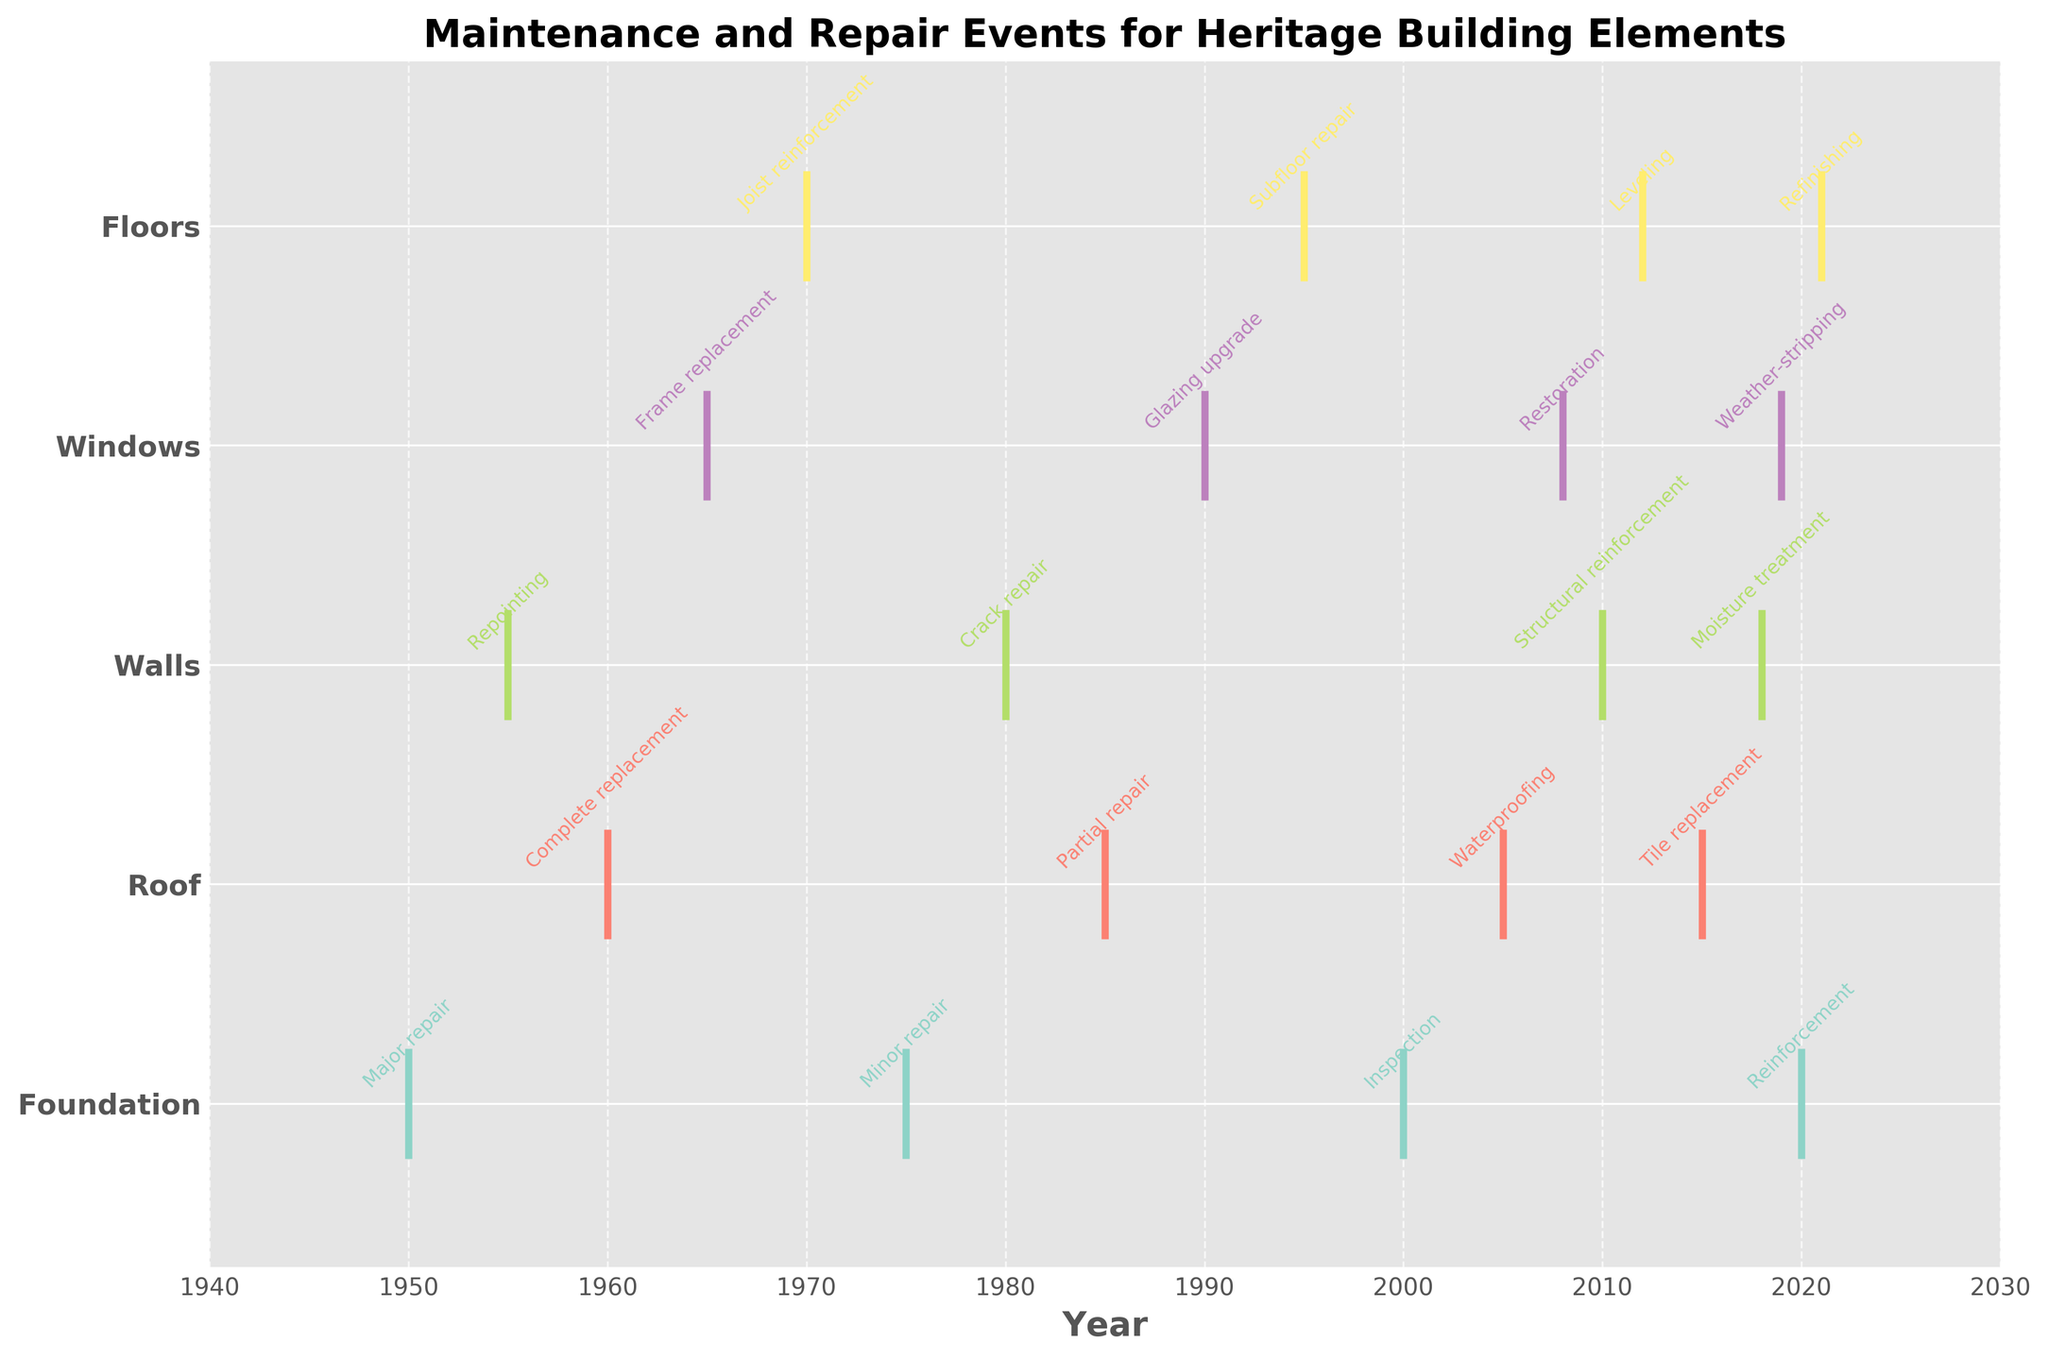What is the title of the plot? The title is usually found at the top center of the plot, and it is used to describe the overall content of the figure.
Answer: Maintenance and Repair Events for Heritage Building Elements Which year shows a complete replacement event for the Roof? Locate the "Roof" on the y-axis, then find the event labeled "Complete replacement" along the x-axis which represents years.
Answer: 1960 How many events occurred for the Walls element? Identify and count the number of events annotated for the Walls element. By looking at the plot, there are annotations for the years 1955, 1980, 2010, 2018.
Answer: 4 Which structural element had a "Glazing upgrade" event? Look for the event labeled "Glazing upgrade" and note down which element it is associated with on the y-axis.
Answer: Windows Which element experienced its first event in the dataset? Determine the earliest year among events for each element. Identify the element associated with that earliest year.
Answer: Foundation What is the interval between the first and last event for the Foundation? Find the years of the first (1950) and last (2020) events for the Foundation element and calculate the interval by subtracting the earlier year from the later year.
Answer: 70 years Which element had the most frequent events over time according to the plot? Count the number of events annotated for each element and compare them to find the element with the highest count.
Answer: Windows and Walls (each with 4 events) Compare the frequency of events for Roof and Floors. Which one had more events? Count and compare the events annotated for Roof and Floors. Roof events are in the years 1960, 1985, 2005, 2015 (total 4), and Floors events are in the years 1970, 1995, 2012, 2021 (total 4).
Answer: Both have the same frequency (4 events each) What type of event occurred in 2018 for the Walls? Locate the year 2018 on the x-axis and identify the annotation corresponding to the Walls element.
Answer: Moisture treatment 